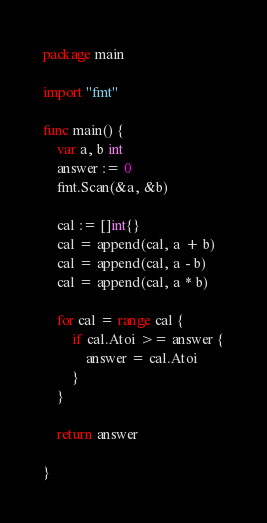<code> <loc_0><loc_0><loc_500><loc_500><_Go_>package main

import "fmt"

func main() {
	var a, b int
	answer := 0
	fmt.Scan(&a, &b)

	cal := []int{}
	cal = append(cal, a + b)
	cal = append(cal, a - b)
	cal = append(cal, a * b)

	for cal = range cal {
		if cal.Atoi >= answer {
			answer = cal.Atoi
		}
	}

	return answer

}</code> 